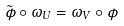Convert formula to latex. <formula><loc_0><loc_0><loc_500><loc_500>\tilde { \phi } \circ \omega _ { U } = \omega _ { V } \circ \phi</formula> 